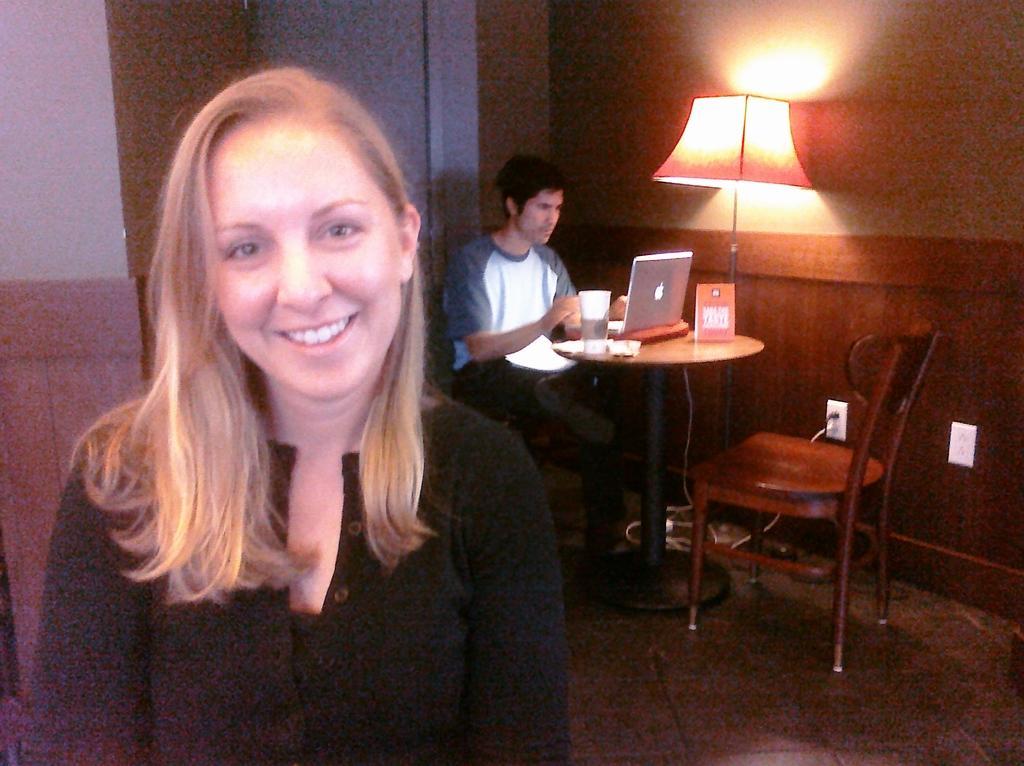Please provide a concise description of this image. In this image there is a woman wearing a black top. Behind her there is a person sitting on the chair. Before him there is a table having a glass, laptop, board. Beside the table there is a lamp. Right side there is a chair on the floor. Background there is a wall. 